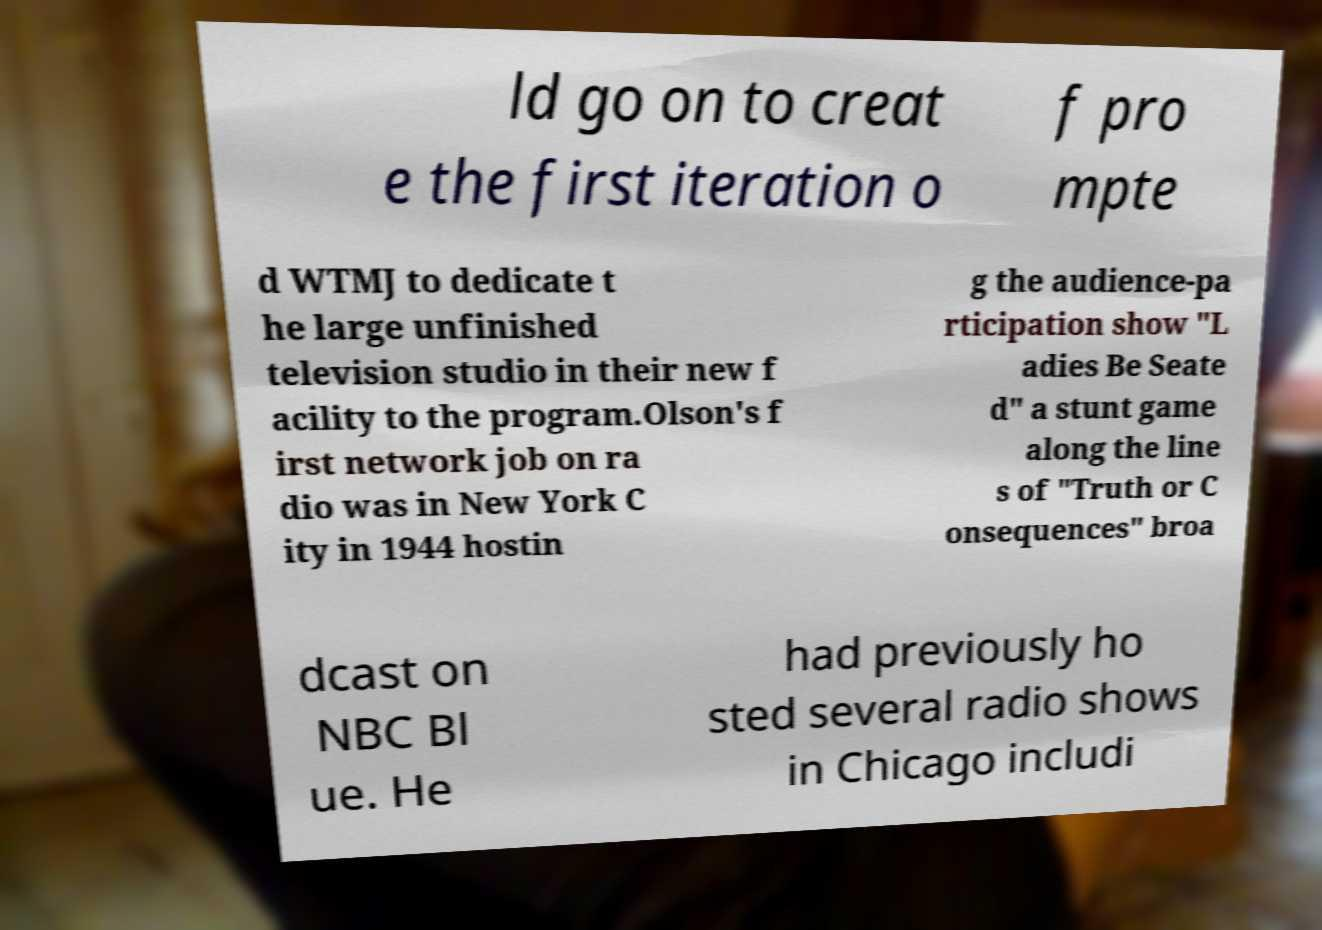Please read and relay the text visible in this image. What does it say? ld go on to creat e the first iteration o f pro mpte d WTMJ to dedicate t he large unfinished television studio in their new f acility to the program.Olson's f irst network job on ra dio was in New York C ity in 1944 hostin g the audience-pa rticipation show "L adies Be Seate d" a stunt game along the line s of "Truth or C onsequences" broa dcast on NBC Bl ue. He had previously ho sted several radio shows in Chicago includi 